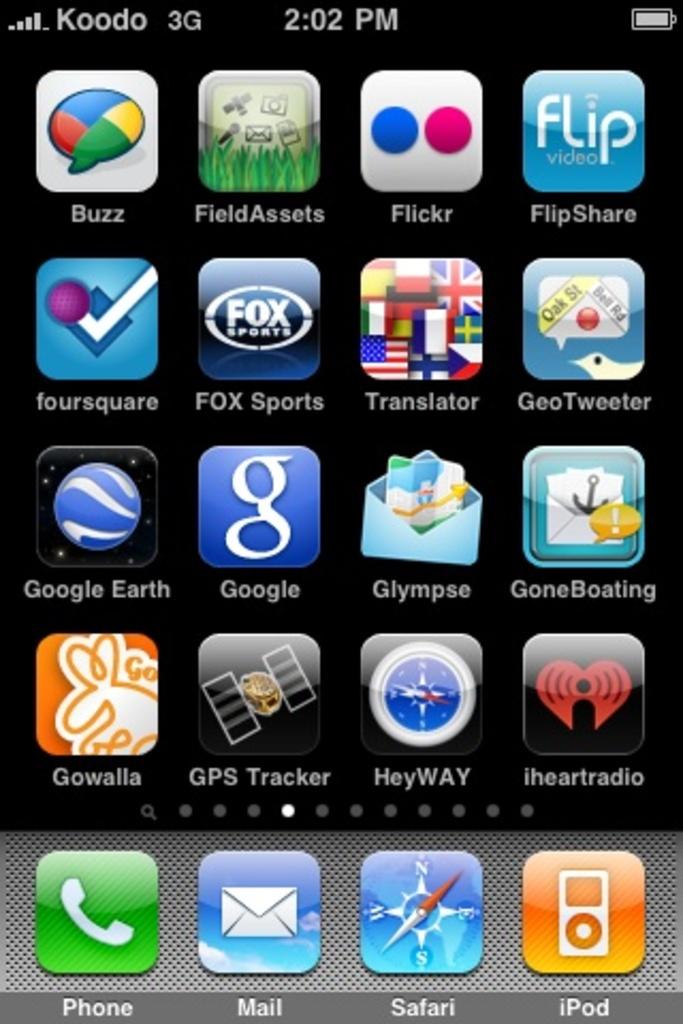What is the name of the first app on the top right?
Provide a short and direct response. Flipshare. What is the time on this phone?
Provide a succinct answer. 2:02. 